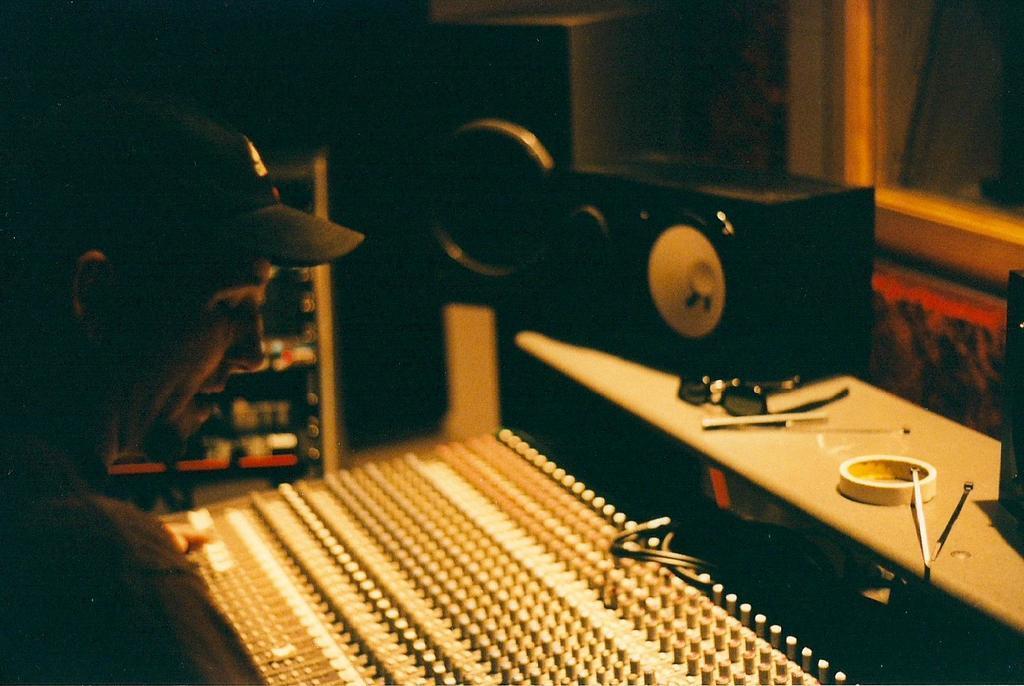Could you give a brief overview of what you see in this image? In this image we can see a person, in front of him there is a musical instrument, on the table, we can see some objects and there is a speaker. 